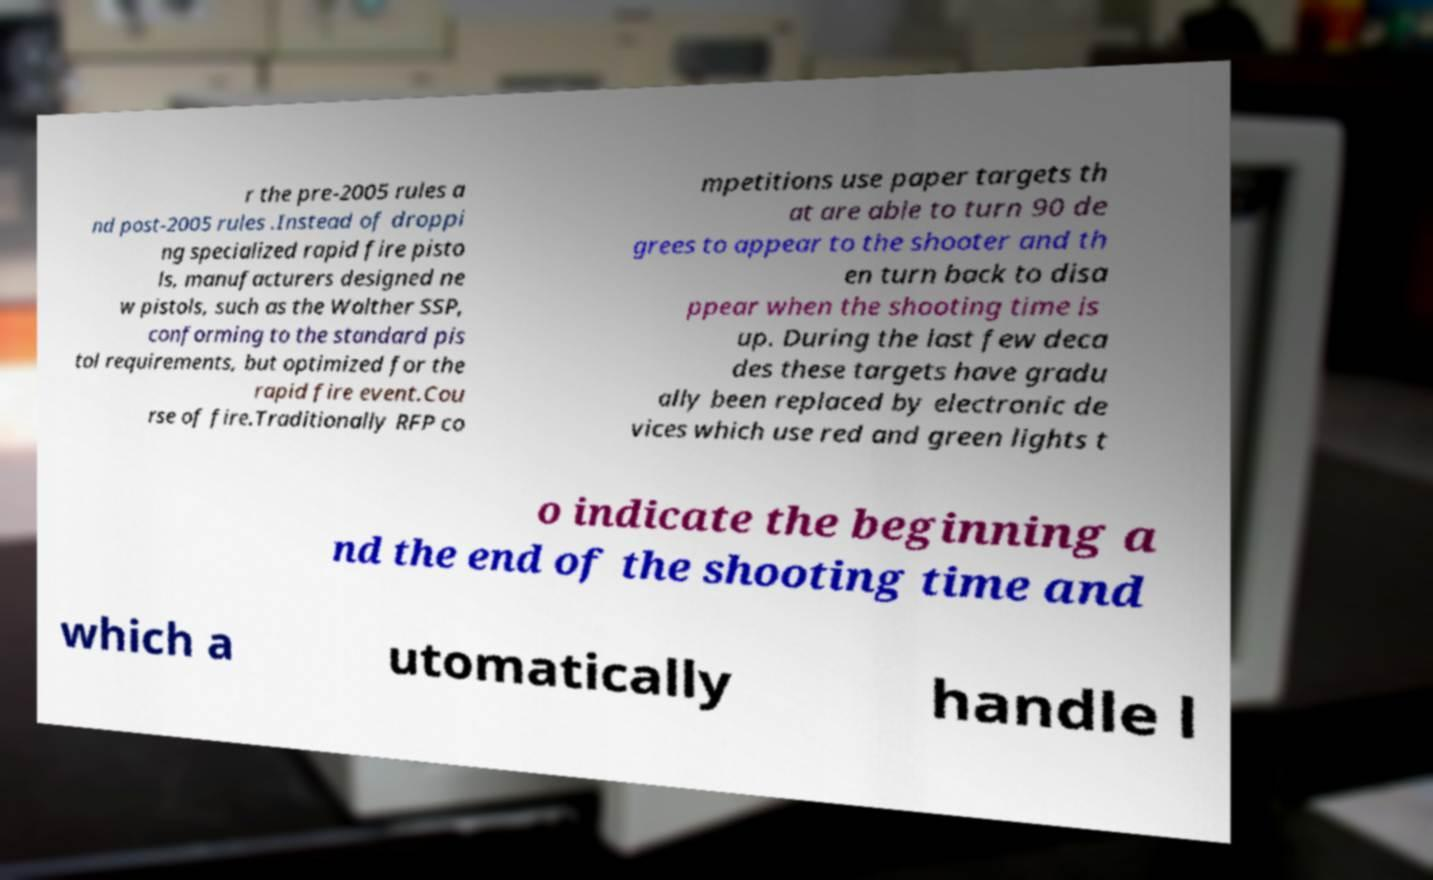Could you assist in decoding the text presented in this image and type it out clearly? r the pre-2005 rules a nd post-2005 rules .Instead of droppi ng specialized rapid fire pisto ls, manufacturers designed ne w pistols, such as the Walther SSP, conforming to the standard pis tol requirements, but optimized for the rapid fire event.Cou rse of fire.Traditionally RFP co mpetitions use paper targets th at are able to turn 90 de grees to appear to the shooter and th en turn back to disa ppear when the shooting time is up. During the last few deca des these targets have gradu ally been replaced by electronic de vices which use red and green lights t o indicate the beginning a nd the end of the shooting time and which a utomatically handle l 